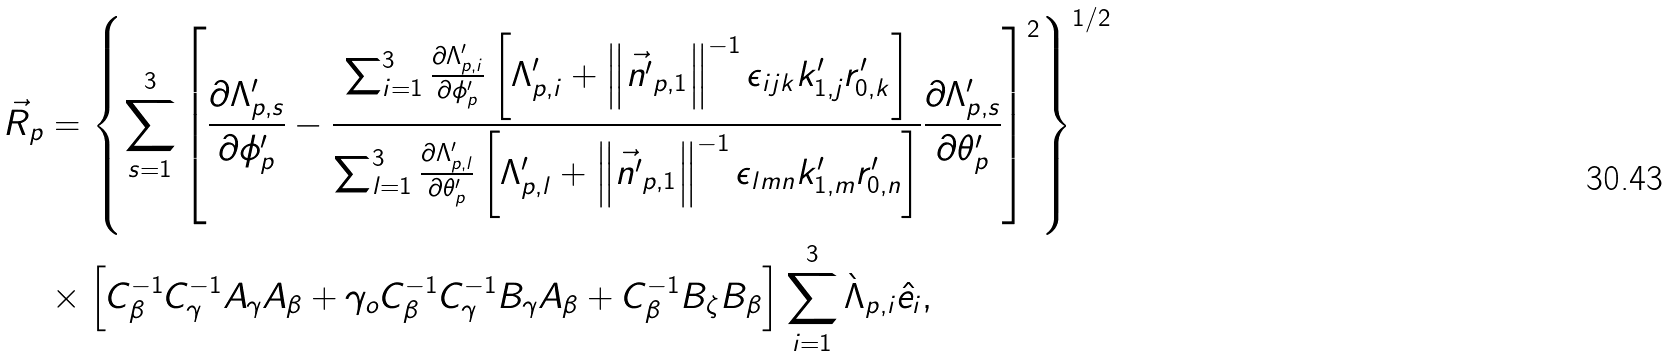<formula> <loc_0><loc_0><loc_500><loc_500>\vec { R } _ { p } & = \left \{ \sum _ { s = 1 } ^ { 3 } \left [ \frac { \partial \Lambda ^ { \prime } _ { p , s } } { \partial \phi ^ { \prime } _ { p } } - \frac { \sum _ { i = 1 } ^ { 3 } \frac { \partial \Lambda ^ { \prime } _ { p , i } } { \partial \phi ^ { \prime } _ { p } } \left [ \Lambda ^ { \prime } _ { p , i } + \left \| \vec { n ^ { \prime } } _ { p , 1 } \right \| ^ { - 1 } \epsilon _ { i j k } k ^ { \prime } _ { 1 , j } r ^ { \prime } _ { 0 , k } \right ] } { \sum _ { l = 1 } ^ { 3 } \frac { \partial \Lambda ^ { \prime } _ { p , l } } { \partial \theta ^ { \prime } _ { p } } \left [ \Lambda ^ { \prime } _ { p , l } + \left \| \vec { n ^ { \prime } } _ { p , 1 } \right \| ^ { - 1 } \epsilon _ { l m n } k ^ { \prime } _ { 1 , m } r ^ { \prime } _ { 0 , n } \right ] } \frac { \partial \Lambda ^ { \prime } _ { p , s } } { \partial \theta ^ { \prime } _ { p } } \right ] ^ { 2 } \right \} ^ { 1 / 2 } \\ & \times \left [ C _ { \beta } ^ { - 1 } C _ { \gamma } ^ { - 1 } A _ { \gamma } A _ { \beta } + \gamma _ { o } C _ { \beta } ^ { - 1 } C _ { \gamma } ^ { - 1 } B _ { \gamma } A _ { \beta } + C _ { \beta } ^ { - 1 } B _ { \zeta } B _ { \beta } \right ] \sum _ { i = 1 } ^ { 3 } \grave { \Lambda } _ { p , i } \hat { e _ { i } } ,</formula> 